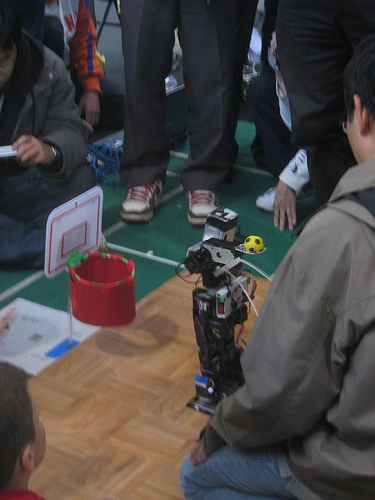<image>
Is there a shoe to the left of the shoe? Yes. From this viewpoint, the shoe is positioned to the left side relative to the shoe. 